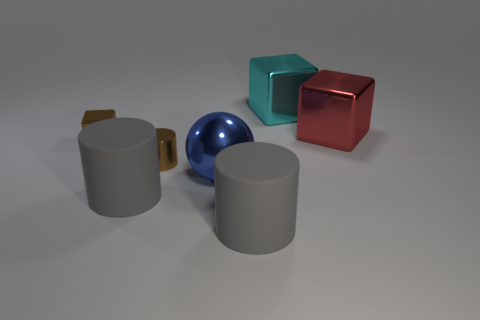Are there any patterns or textures on the objects? The objects appear to have a smooth surface without any discernible patterns or textures. They reflect light in a way that suggests they are made of materials with a matte finish, like painted metal or plastic, with the exception of the shinier sphere. 